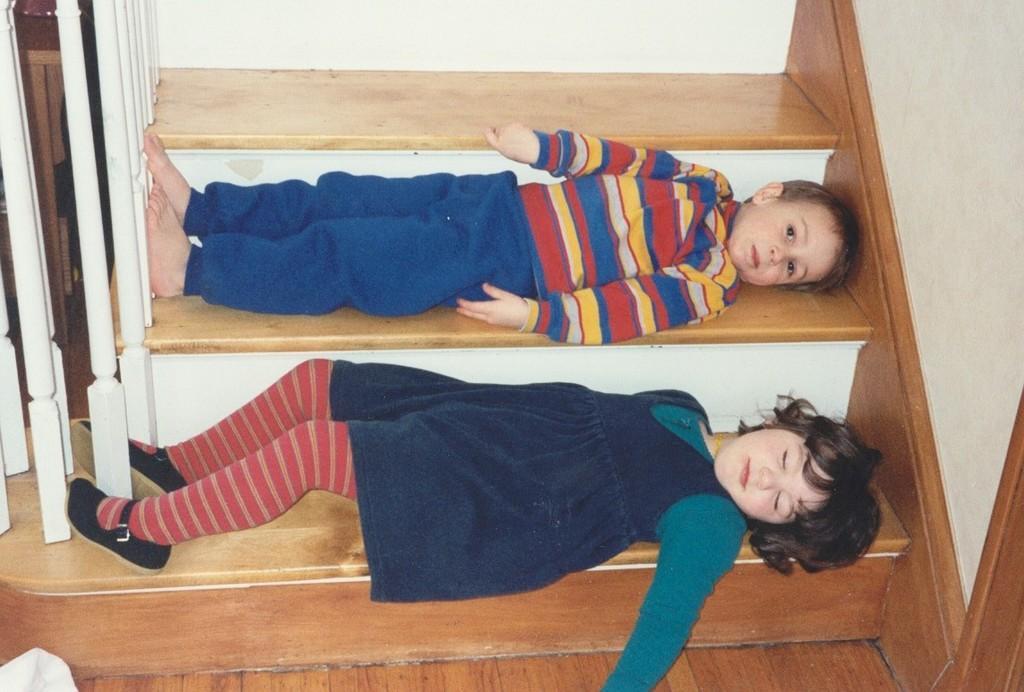Describe this image in one or two sentences. This image is taken indoors. On the right side of the image there is a wall. On the left side of the image there is a railing. At the bottom of the image there is a floor. In the middle of the image two kids are lying on the stairs. 